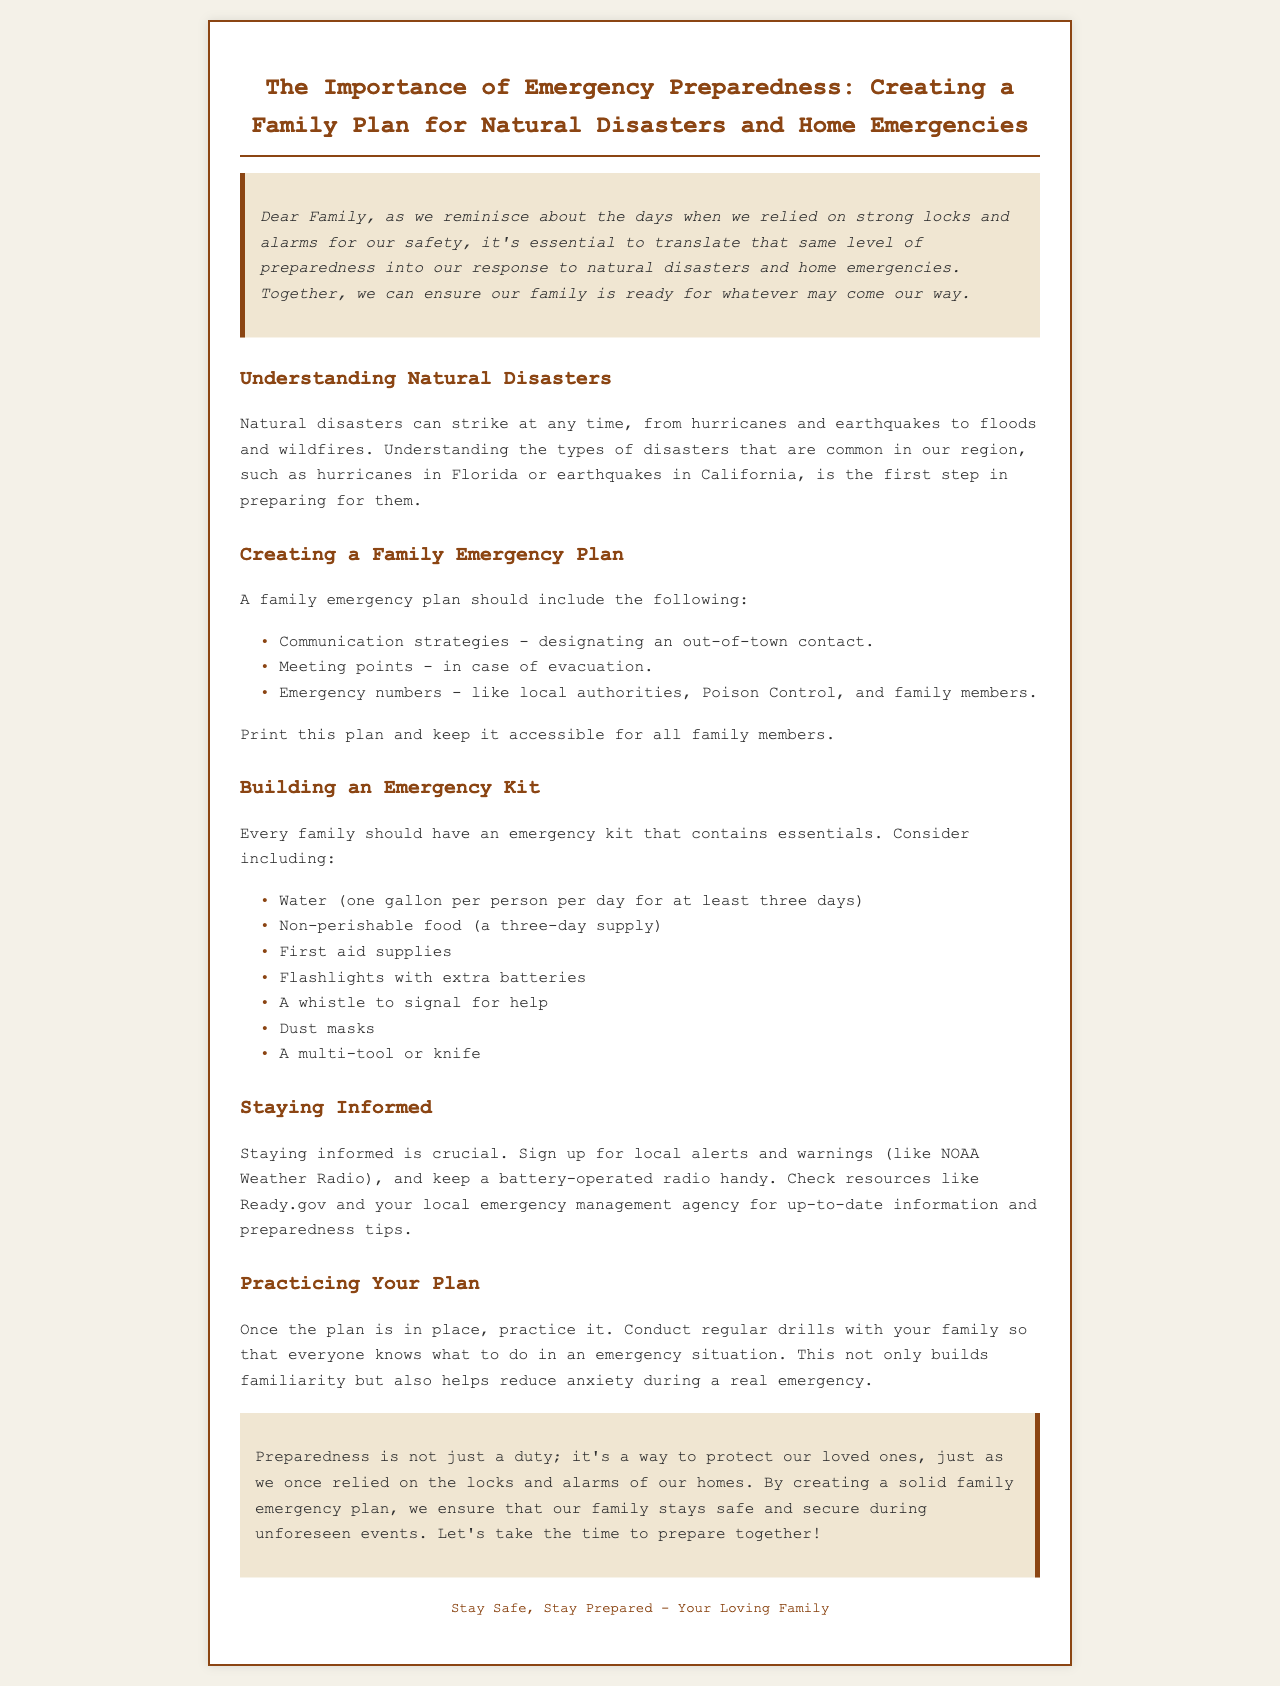What is the main topic of the newsletter? The main topic of the newsletter discusses the importance of preparing for emergencies by creating a family plan for natural disasters and home emergencies.
Answer: Emergency Preparedness What is one type of disaster mentioned? The document lists various types of disasters to be aware of, including hurricanes which are common in certain areas.
Answer: Hurricanes What is included in a family emergency plan? The family emergency plan should include communication strategies, meeting points, and emergency numbers as outlined in the document.
Answer: Communication strategies How much water should be included in the emergency kit per person? The newsletter specifies the amount of water to pack in the emergency kit to sustain each person for three days.
Answer: One gallon What should families sign up for to stay informed? The document emphasizes the importance of staying up-to-date with alerts and warnings to ensure safety during emergencies.
Answer: Local alerts What should be done regularly to ensure familiarity with the emergency plan? The newsletter suggests a proactive approach to ensure all family members know their roles and actions during an emergency by practicing the plan.
Answer: Conduct drills What is the conclusion's message about preparedness? The conclusion underscores the significance of preparedness as a duty to safeguard family members during emergencies.
Answer: Protect our loved ones What type of resource is suggested for obtaining up-to-date information? The document points to specific resources for acquiring the latest preparedness information, highlighting government websites and agencies.
Answer: Ready.gov 